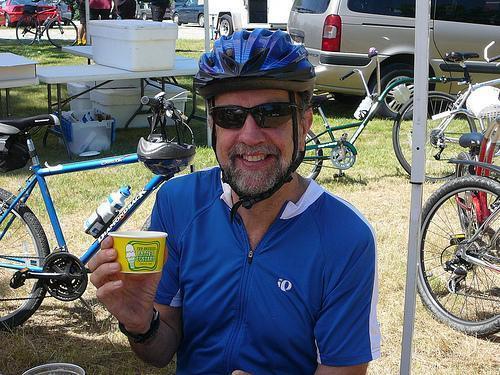How many people are in the photo?
Give a very brief answer. 1. How many bicycles can be seen?
Give a very brief answer. 4. How many red chairs are in this image?
Give a very brief answer. 0. 